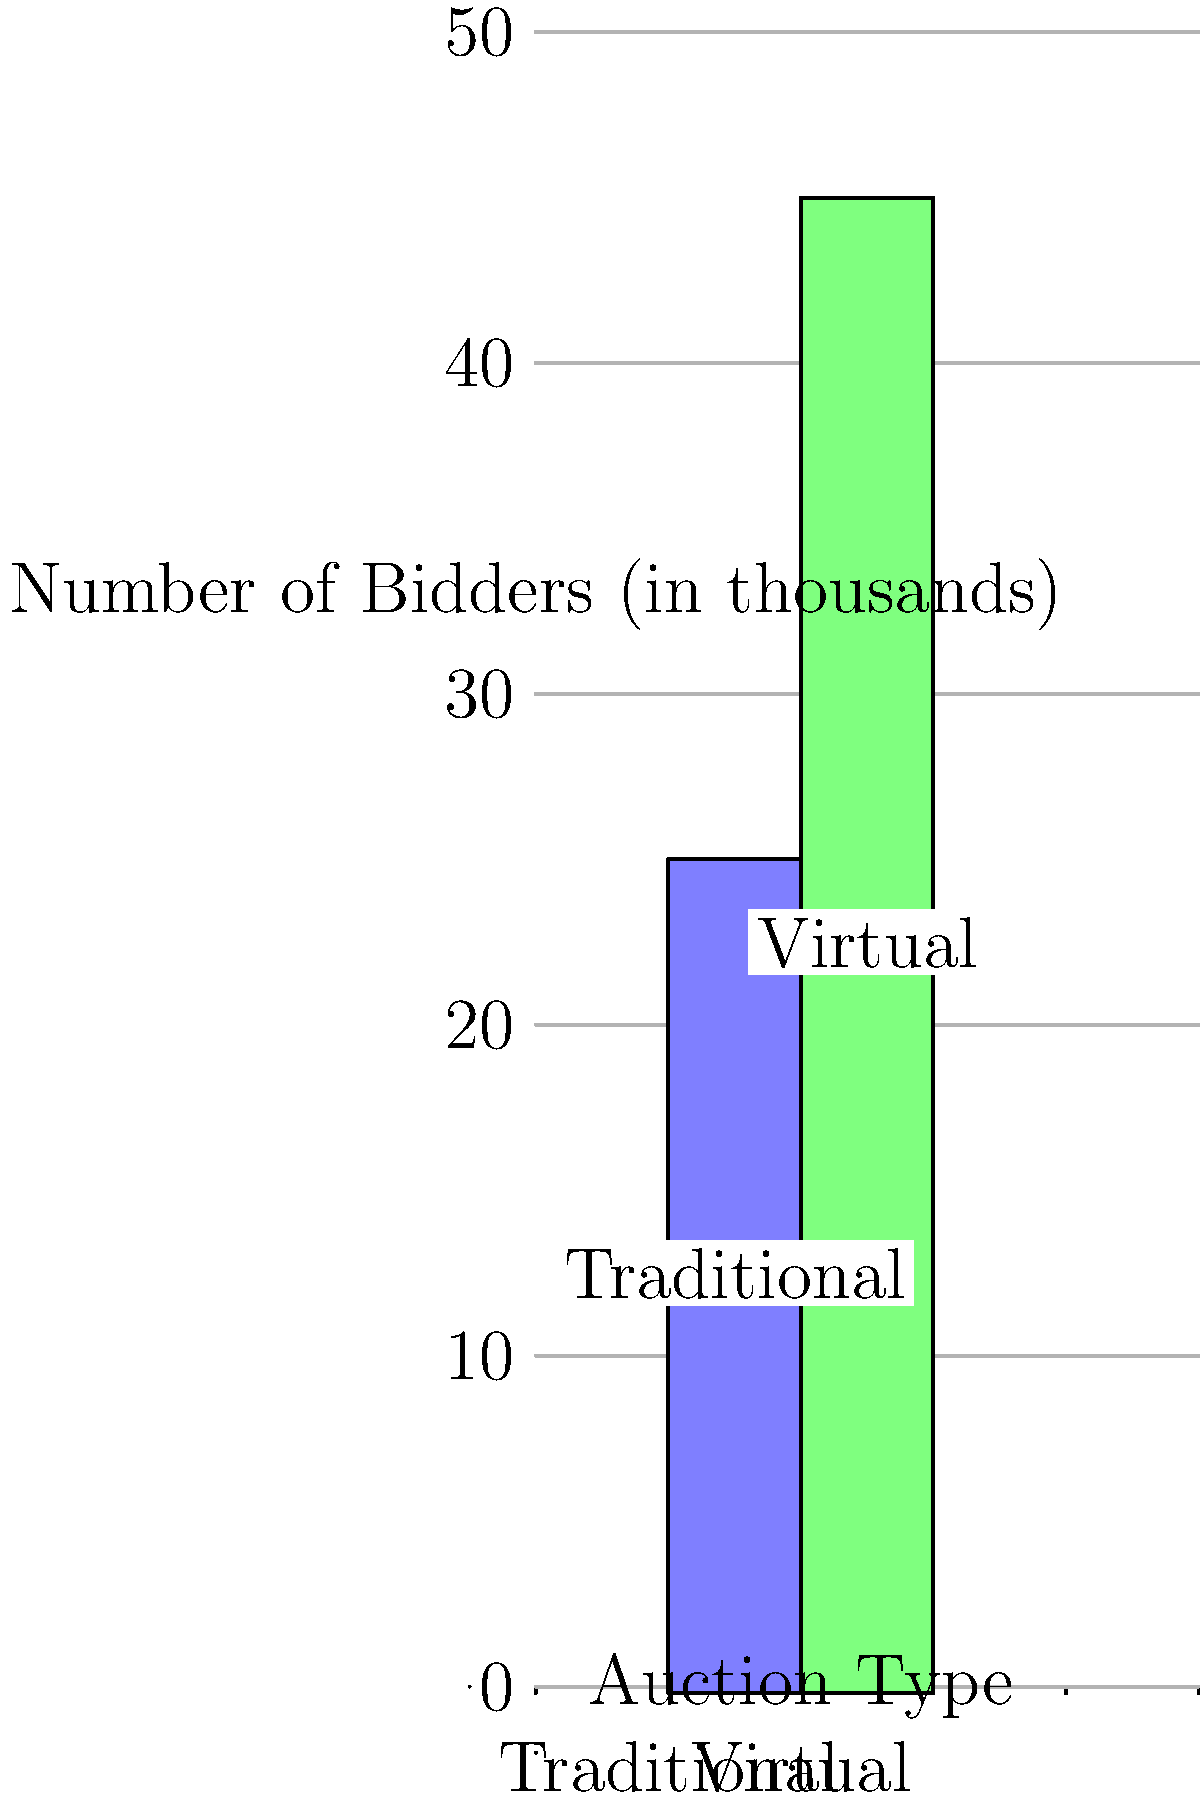Based on the bar graph comparing the reach of virtual and traditional art auctions, how many more bidders (in thousands) does the virtual auction attract compared to the traditional auction? To find the difference in the number of bidders between virtual and traditional auctions, we need to:

1. Identify the number of bidders for each auction type:
   - Traditional auction: 25 thousand bidders
   - Virtual auction: 45 thousand bidders

2. Subtract the number of bidders in the traditional auction from the virtual auction:
   $45 - 25 = 20$ thousand bidders

Therefore, the virtual auction attracts 20 thousand more bidders than the traditional auction.
Answer: 20 thousand 